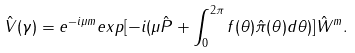Convert formula to latex. <formula><loc_0><loc_0><loc_500><loc_500>\hat { V } ( \gamma ) = e ^ { - i \mu m } e x p [ - i ( \mu \hat { P } + \int _ { 0 } ^ { 2 \pi } f ( \theta ) \hat { \pi } ( \theta ) d \theta ) ] \hat { W } ^ { m } .</formula> 